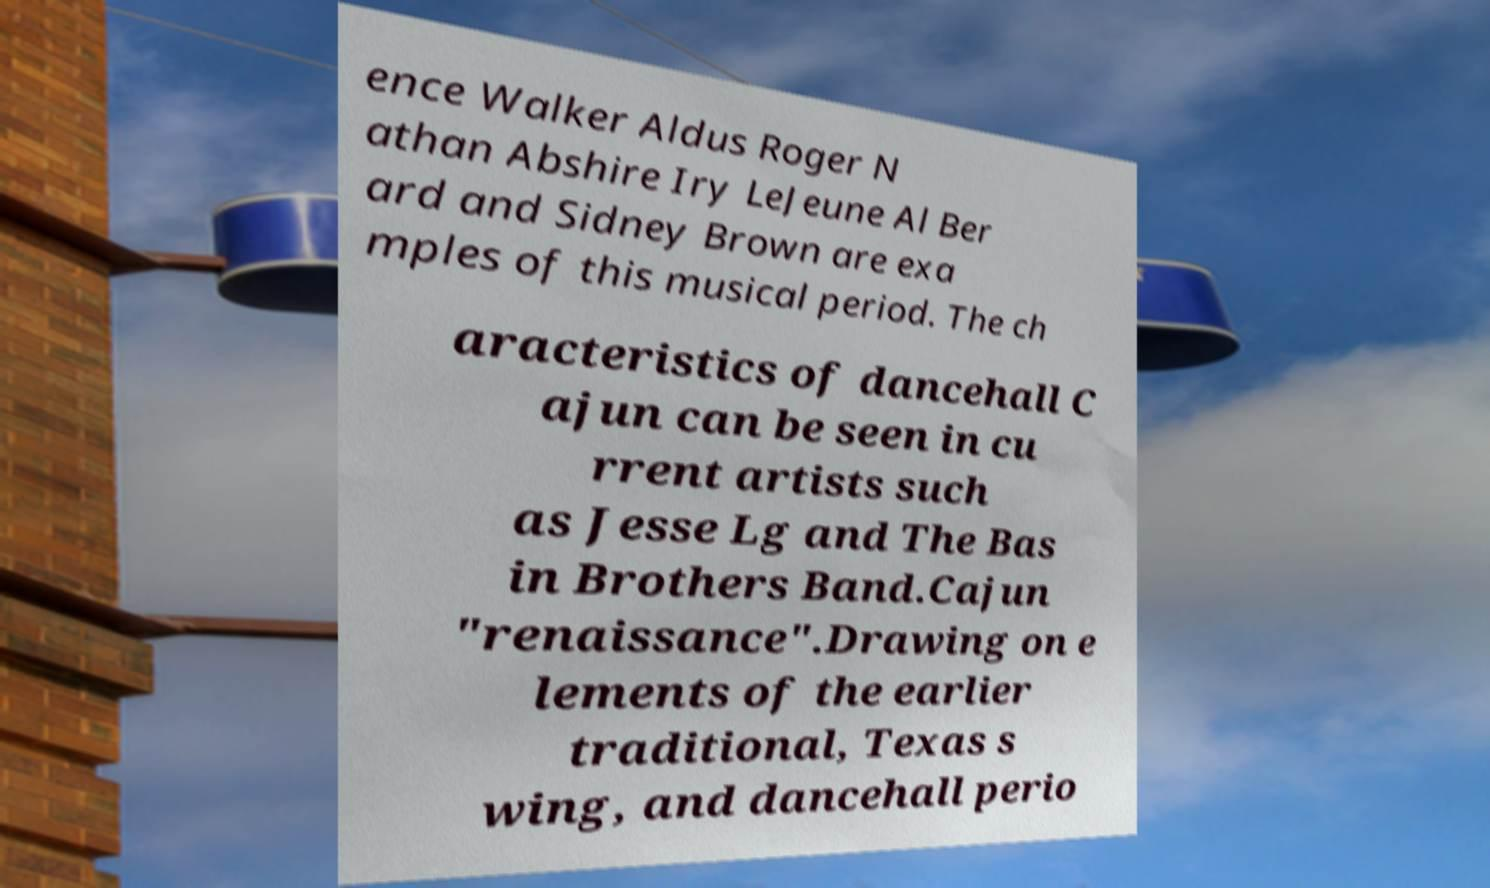For documentation purposes, I need the text within this image transcribed. Could you provide that? ence Walker Aldus Roger N athan Abshire Iry LeJeune Al Ber ard and Sidney Brown are exa mples of this musical period. The ch aracteristics of dancehall C ajun can be seen in cu rrent artists such as Jesse Lg and The Bas in Brothers Band.Cajun "renaissance".Drawing on e lements of the earlier traditional, Texas s wing, and dancehall perio 